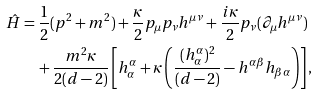<formula> <loc_0><loc_0><loc_500><loc_500>\hat { H } & = \frac { 1 } { 2 } ( p ^ { 2 } + m ^ { 2 } ) + \frac { \kappa } { 2 } p _ { \mu } p _ { \nu } h ^ { \mu \nu } + \frac { i \kappa } { 2 } p _ { \nu } ( \partial _ { \mu } h ^ { \mu \nu } ) \\ & \quad + \frac { m ^ { 2 } \kappa } { 2 ( d - 2 ) } \left [ h ^ { \alpha } _ { \alpha } + \kappa \left ( \frac { ( h ^ { \alpha } _ { \alpha } ) ^ { 2 } } { ( d - 2 ) } - h ^ { \alpha \beta } h _ { \beta \alpha } \right ) \right ] ,</formula> 